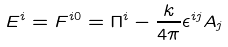<formula> <loc_0><loc_0><loc_500><loc_500>E ^ { i } = F ^ { i 0 } = \Pi ^ { i } - \frac { k } { 4 \pi } \epsilon ^ { i j } A _ { j }</formula> 